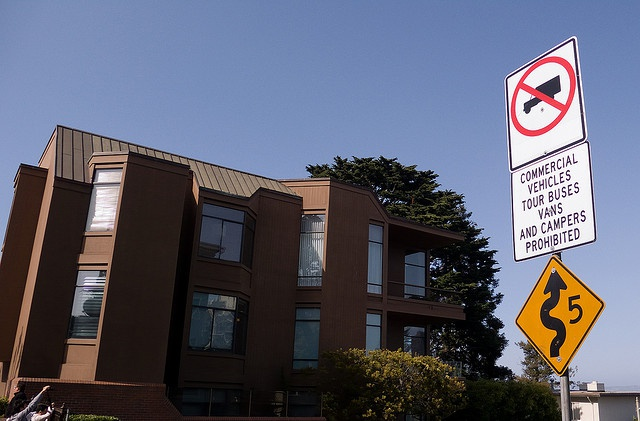Describe the objects in this image and their specific colors. I can see stop sign in gray, white, salmon, red, and black tones, people in gray, black, darkgray, and lightgray tones, people in gray, black, lightgray, darkgray, and maroon tones, and people in gray, black, brown, maroon, and salmon tones in this image. 